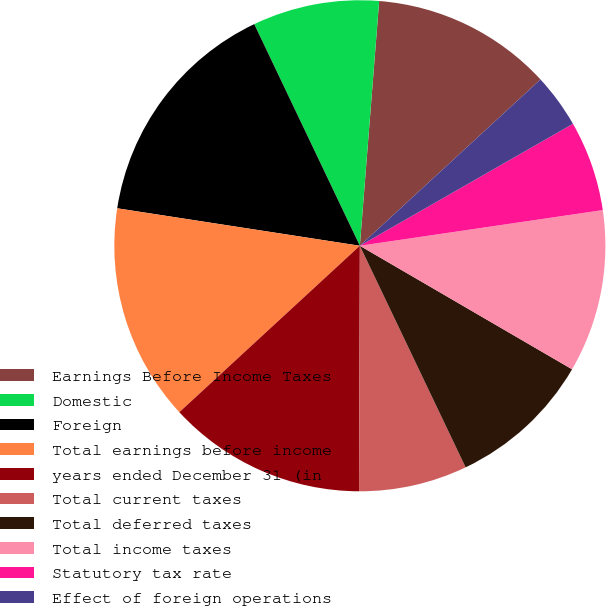<chart> <loc_0><loc_0><loc_500><loc_500><pie_chart><fcel>Earnings Before Income Taxes<fcel>Domestic<fcel>Foreign<fcel>Total earnings before income<fcel>years ended December 31 (in<fcel>Total current taxes<fcel>Total deferred taxes<fcel>Total income taxes<fcel>Statutory tax rate<fcel>Effect of foreign operations<nl><fcel>11.9%<fcel>8.33%<fcel>15.48%<fcel>14.29%<fcel>13.09%<fcel>7.14%<fcel>9.52%<fcel>10.71%<fcel>5.95%<fcel>3.57%<nl></chart> 